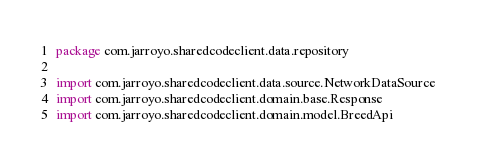<code> <loc_0><loc_0><loc_500><loc_500><_Kotlin_>package com.jarroyo.sharedcodeclient.data.repository

import com.jarroyo.sharedcodeclient.data.source.NetworkDataSource
import com.jarroyo.sharedcodeclient.domain.base.Response
import com.jarroyo.sharedcodeclient.domain.model.BreedApi</code> 